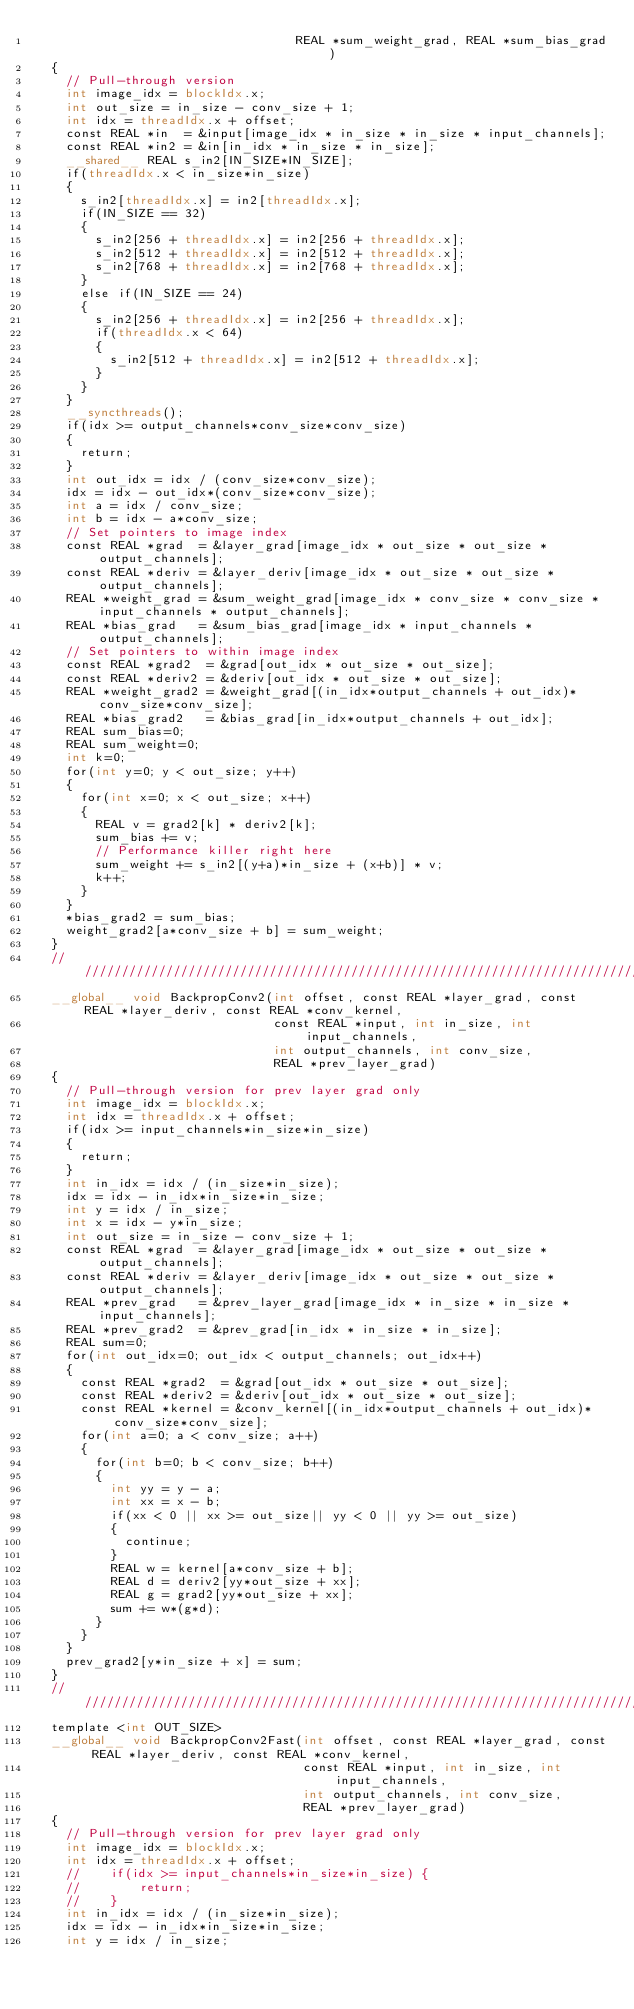<code> <loc_0><loc_0><loc_500><loc_500><_Cuda_>	                                 REAL *sum_weight_grad, REAL *sum_bias_grad)
	{
		// Pull-through version
		int image_idx = blockIdx.x;
		int out_size = in_size - conv_size + 1;
		int idx = threadIdx.x + offset;
		const REAL *in  = &input[image_idx * in_size * in_size * input_channels];
		const REAL *in2 = &in[in_idx * in_size * in_size];
		__shared__ REAL s_in2[IN_SIZE*IN_SIZE];
		if(threadIdx.x < in_size*in_size)
		{
			s_in2[threadIdx.x] = in2[threadIdx.x];
			if(IN_SIZE == 32)
			{
				s_in2[256 + threadIdx.x] = in2[256 + threadIdx.x];
				s_in2[512 + threadIdx.x] = in2[512 + threadIdx.x];
				s_in2[768 + threadIdx.x] = in2[768 + threadIdx.x];
			}
			else if(IN_SIZE == 24)
			{
				s_in2[256 + threadIdx.x] = in2[256 + threadIdx.x];
				if(threadIdx.x < 64)
				{
					s_in2[512 + threadIdx.x] = in2[512 + threadIdx.x];
				}
			}
		}
		__syncthreads();
		if(idx >= output_channels*conv_size*conv_size)
		{
			return;
		}
		int out_idx = idx / (conv_size*conv_size);
		idx = idx - out_idx*(conv_size*conv_size);
		int a = idx / conv_size;
		int b = idx - a*conv_size;
		// Set pointers to image index
		const REAL *grad  = &layer_grad[image_idx * out_size * out_size * output_channels];
		const REAL *deriv = &layer_deriv[image_idx * out_size * out_size * output_channels];
		REAL *weight_grad = &sum_weight_grad[image_idx * conv_size * conv_size * input_channels * output_channels];
		REAL *bias_grad   = &sum_bias_grad[image_idx * input_channels * output_channels];
		// Set pointers to within image index
		const REAL *grad2  = &grad[out_idx * out_size * out_size];
		const REAL *deriv2 = &deriv[out_idx * out_size * out_size];
		REAL *weight_grad2 = &weight_grad[(in_idx*output_channels + out_idx)*conv_size*conv_size];
		REAL *bias_grad2   = &bias_grad[in_idx*output_channels + out_idx];
		REAL sum_bias=0;
		REAL sum_weight=0;
		int k=0;
		for(int y=0; y < out_size; y++)
		{
			for(int x=0; x < out_size; x++)
			{
				REAL v = grad2[k] * deriv2[k];
				sum_bias += v;
				// Performance killer right here
				sum_weight += s_in2[(y+a)*in_size + (x+b)] * v;
				k++;
			}
		}
		*bias_grad2 = sum_bias;
		weight_grad2[a*conv_size + b] = sum_weight;
	}
	//////////////////////////////////////////////////////////////////////////////////////////////////////////
	__global__ void BackpropConv2(int offset, const REAL *layer_grad, const REAL *layer_deriv, const REAL *conv_kernel,
	                              const REAL *input, int in_size, int input_channels,
	                              int output_channels, int conv_size,
	                              REAL *prev_layer_grad)
	{
		// Pull-through version for prev layer grad only
		int image_idx = blockIdx.x;
		int idx = threadIdx.x + offset;
		if(idx >= input_channels*in_size*in_size)
		{
			return;
		}
		int in_idx = idx / (in_size*in_size);
		idx = idx - in_idx*in_size*in_size;
		int y = idx / in_size;
		int x = idx - y*in_size;
		int out_size = in_size - conv_size + 1;
		const REAL *grad  = &layer_grad[image_idx * out_size * out_size * output_channels];
		const REAL *deriv = &layer_deriv[image_idx * out_size * out_size * output_channels];
		REAL *prev_grad   = &prev_layer_grad[image_idx * in_size * in_size * input_channels];
		REAL *prev_grad2  = &prev_grad[in_idx * in_size * in_size];
		REAL sum=0;
		for(int out_idx=0; out_idx < output_channels; out_idx++)
		{
			const REAL *grad2  = &grad[out_idx * out_size * out_size];
			const REAL *deriv2 = &deriv[out_idx * out_size * out_size];
			const REAL *kernel = &conv_kernel[(in_idx*output_channels + out_idx)*conv_size*conv_size];
			for(int a=0; a < conv_size; a++)
			{
				for(int b=0; b < conv_size; b++)
				{
					int yy = y - a;
					int xx = x - b;
					if(xx < 0 || xx >= out_size|| yy < 0 || yy >= out_size)
					{
						continue;
					}
					REAL w = kernel[a*conv_size + b];
					REAL d = deriv2[yy*out_size + xx];
					REAL g = grad2[yy*out_size + xx];
					sum += w*(g*d);
				}
			}
		}
		prev_grad2[y*in_size + x] = sum;
	}
	//////////////////////////////////////////////////////////////////////////////////////////////////////////
	template <int OUT_SIZE>
	__global__ void BackpropConv2Fast(int offset, const REAL *layer_grad, const REAL *layer_deriv, const REAL *conv_kernel,
	                                  const REAL *input, int in_size, int input_channels,
	                                  int output_channels, int conv_size,
	                                  REAL *prev_layer_grad)
	{
		// Pull-through version for prev layer grad only
		int image_idx = blockIdx.x;
		int idx = threadIdx.x + offset;
		//    if(idx >= input_channels*in_size*in_size) {
		//        return;
		//    }
		int in_idx = idx / (in_size*in_size);
		idx = idx - in_idx*in_size*in_size;
		int y = idx / in_size;</code> 